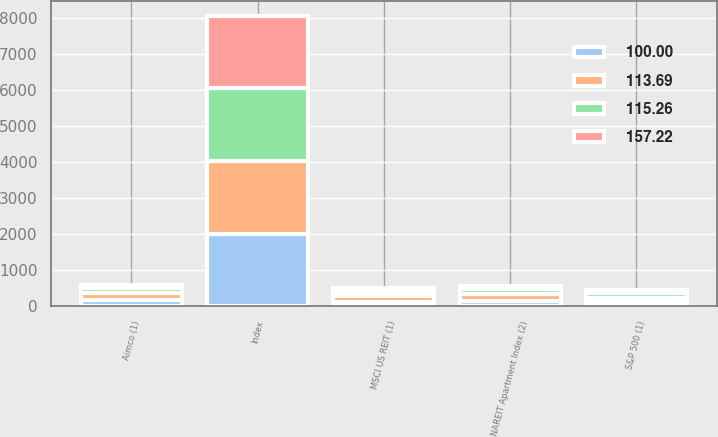Convert chart to OTSL. <chart><loc_0><loc_0><loc_500><loc_500><stacked_bar_chart><ecel><fcel>Index<fcel>Aimco (1)<fcel>MSCI US REIT (1)<fcel>NAREIT Apartment Index (2)<fcel>S&P 500 (1)<nl><fcel>157.22<fcel>2013<fcel>100<fcel>100<fcel>100<fcel>100<nl><fcel>115.26<fcel>2014<fcel>148.04<fcel>130.38<fcel>139.62<fcel>113.69<nl><fcel>100<fcel>2015<fcel>164.54<fcel>133.67<fcel>162.6<fcel>115.26<nl><fcel>113.69<fcel>2016<fcel>192.98<fcel>145.16<fcel>167.24<fcel>129.05<nl></chart> 